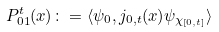<formula> <loc_0><loc_0><loc_500><loc_500>P ^ { t } _ { 0 1 } ( x ) \colon = \langle \psi _ { 0 } , j _ { 0 , t } ( x ) \psi _ { \chi _ { [ 0 , t ] } } \rangle</formula> 